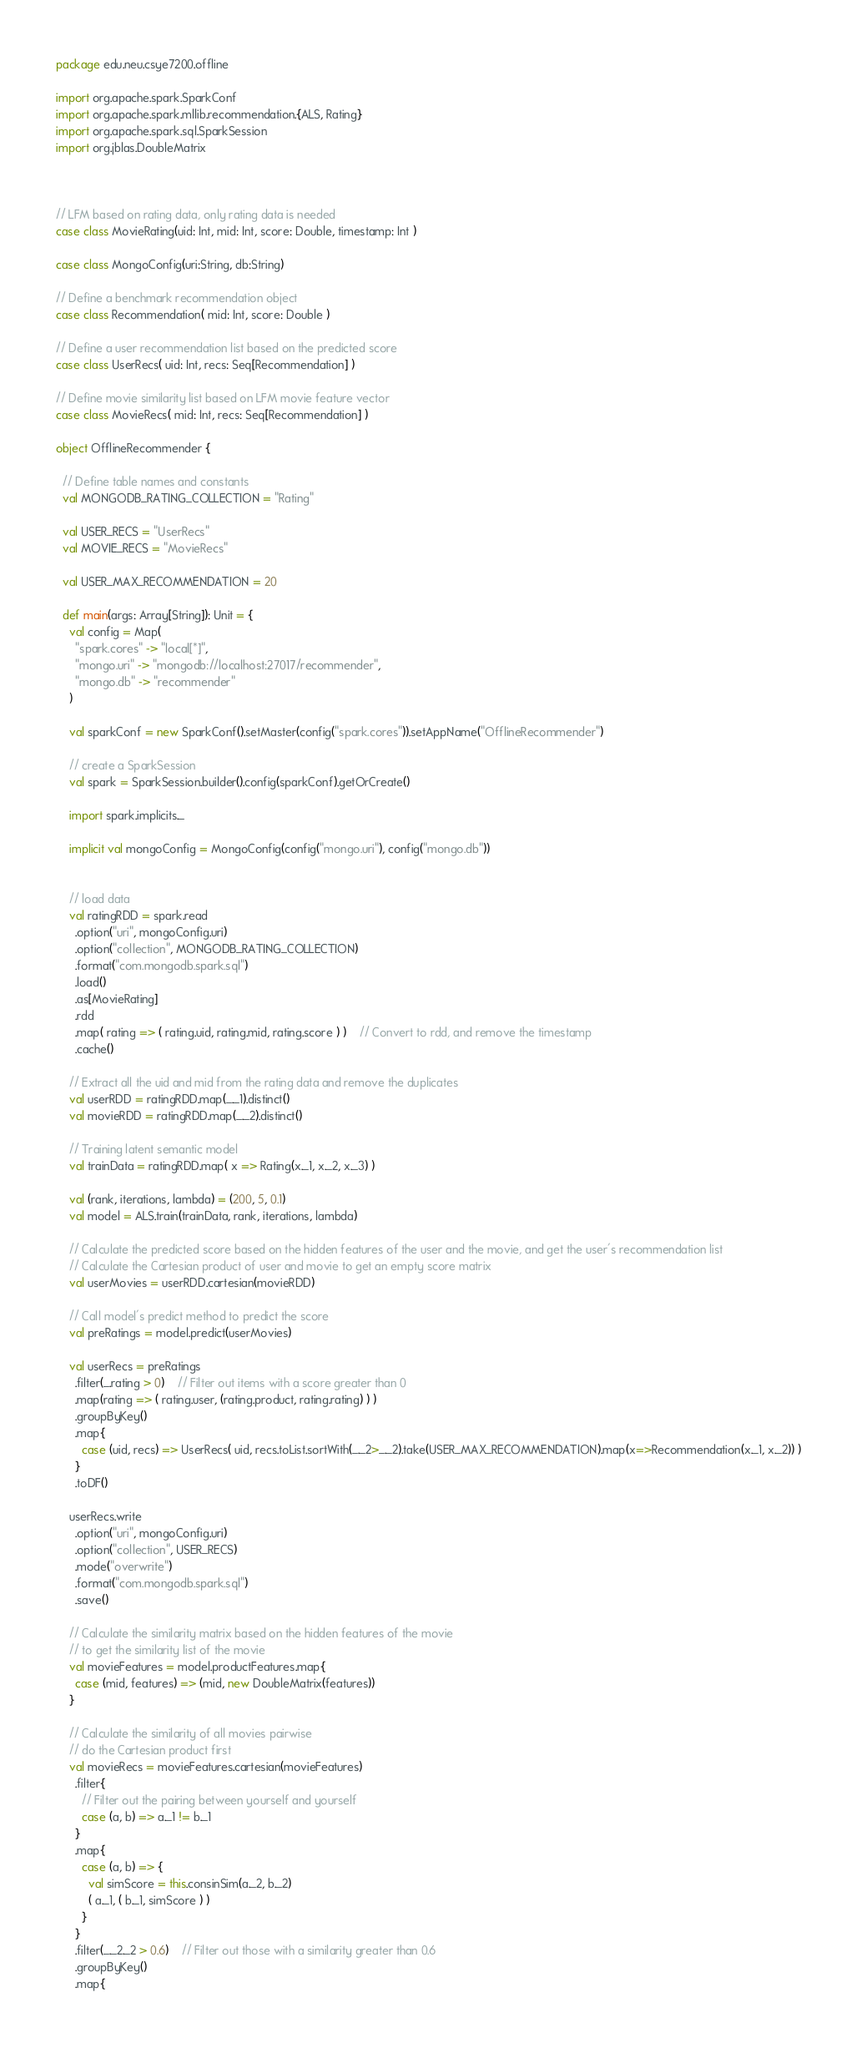Convert code to text. <code><loc_0><loc_0><loc_500><loc_500><_Scala_>package edu.neu.csye7200.offline

import org.apache.spark.SparkConf
import org.apache.spark.mllib.recommendation.{ALS, Rating}
import org.apache.spark.sql.SparkSession
import org.jblas.DoubleMatrix



// LFM based on rating data, only rating data is needed
case class MovieRating(uid: Int, mid: Int, score: Double, timestamp: Int )

case class MongoConfig(uri:String, db:String)

// Define a benchmark recommendation object
case class Recommendation( mid: Int, score: Double )

// Define a user recommendation list based on the predicted score
case class UserRecs( uid: Int, recs: Seq[Recommendation] )

// Define movie similarity list based on LFM movie feature vector
case class MovieRecs( mid: Int, recs: Seq[Recommendation] )

object OfflineRecommender {

  // Define table names and constants
  val MONGODB_RATING_COLLECTION = "Rating"

  val USER_RECS = "UserRecs"
  val MOVIE_RECS = "MovieRecs"

  val USER_MAX_RECOMMENDATION = 20

  def main(args: Array[String]): Unit = {
    val config = Map(
      "spark.cores" -> "local[*]",
      "mongo.uri" -> "mongodb://localhost:27017/recommender",
      "mongo.db" -> "recommender"
    )

    val sparkConf = new SparkConf().setMaster(config("spark.cores")).setAppName("OfflineRecommender")

    // create a SparkSession
    val spark = SparkSession.builder().config(sparkConf).getOrCreate()

    import spark.implicits._

    implicit val mongoConfig = MongoConfig(config("mongo.uri"), config("mongo.db"))


    // load data
    val ratingRDD = spark.read
      .option("uri", mongoConfig.uri)
      .option("collection", MONGODB_RATING_COLLECTION)
      .format("com.mongodb.spark.sql")
      .load()
      .as[MovieRating]
      .rdd
      .map( rating => ( rating.uid, rating.mid, rating.score ) )    // Convert to rdd, and remove the timestamp
      .cache()

    // Extract all the uid and mid from the rating data and remove the duplicates
    val userRDD = ratingRDD.map(_._1).distinct()
    val movieRDD = ratingRDD.map(_._2).distinct()

    // Training latent semantic model
    val trainData = ratingRDD.map( x => Rating(x._1, x._2, x._3) )

    val (rank, iterations, lambda) = (200, 5, 0.1)
    val model = ALS.train(trainData, rank, iterations, lambda)

    // Calculate the predicted score based on the hidden features of the user and the movie, and get the user's recommendation list
    // Calculate the Cartesian product of user and movie to get an empty score matrix
    val userMovies = userRDD.cartesian(movieRDD)

    // Call model's predict method to predict the score
    val preRatings = model.predict(userMovies)

    val userRecs = preRatings
      .filter(_.rating > 0)    // Filter out items with a score greater than 0
      .map(rating => ( rating.user, (rating.product, rating.rating) ) )
      .groupByKey()
      .map{
        case (uid, recs) => UserRecs( uid, recs.toList.sortWith(_._2>_._2).take(USER_MAX_RECOMMENDATION).map(x=>Recommendation(x._1, x._2)) )
      }
      .toDF()

    userRecs.write
      .option("uri", mongoConfig.uri)
      .option("collection", USER_RECS)
      .mode("overwrite")
      .format("com.mongodb.spark.sql")
      .save()

    // Calculate the similarity matrix based on the hidden features of the movie
    // to get the similarity list of the movie
    val movieFeatures = model.productFeatures.map{
      case (mid, features) => (mid, new DoubleMatrix(features))
    }

    // Calculate the similarity of all movies pairwise
    // do the Cartesian product first
    val movieRecs = movieFeatures.cartesian(movieFeatures)
      .filter{
        // Filter out the pairing between yourself and yourself
        case (a, b) => a._1 != b._1
      }
      .map{
        case (a, b) => {
          val simScore = this.consinSim(a._2, b._2)
          ( a._1, ( b._1, simScore ) )
        }
      }
      .filter(_._2._2 > 0.6)    // Filter out those with a similarity greater than 0.6
      .groupByKey()
      .map{</code> 